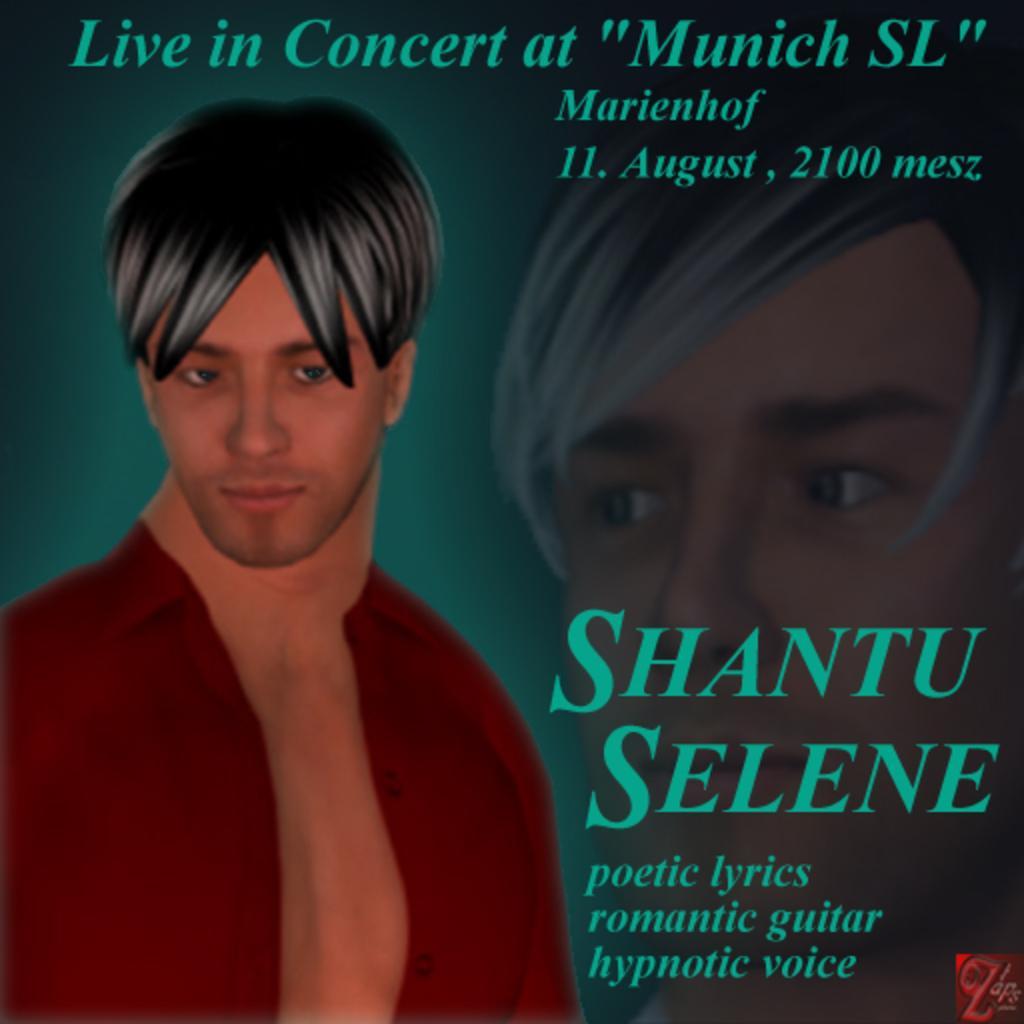How would you summarize this image in a sentence or two? In the foreground of this image, there is an image of a man and some text. We can also see a person's face on the right. 